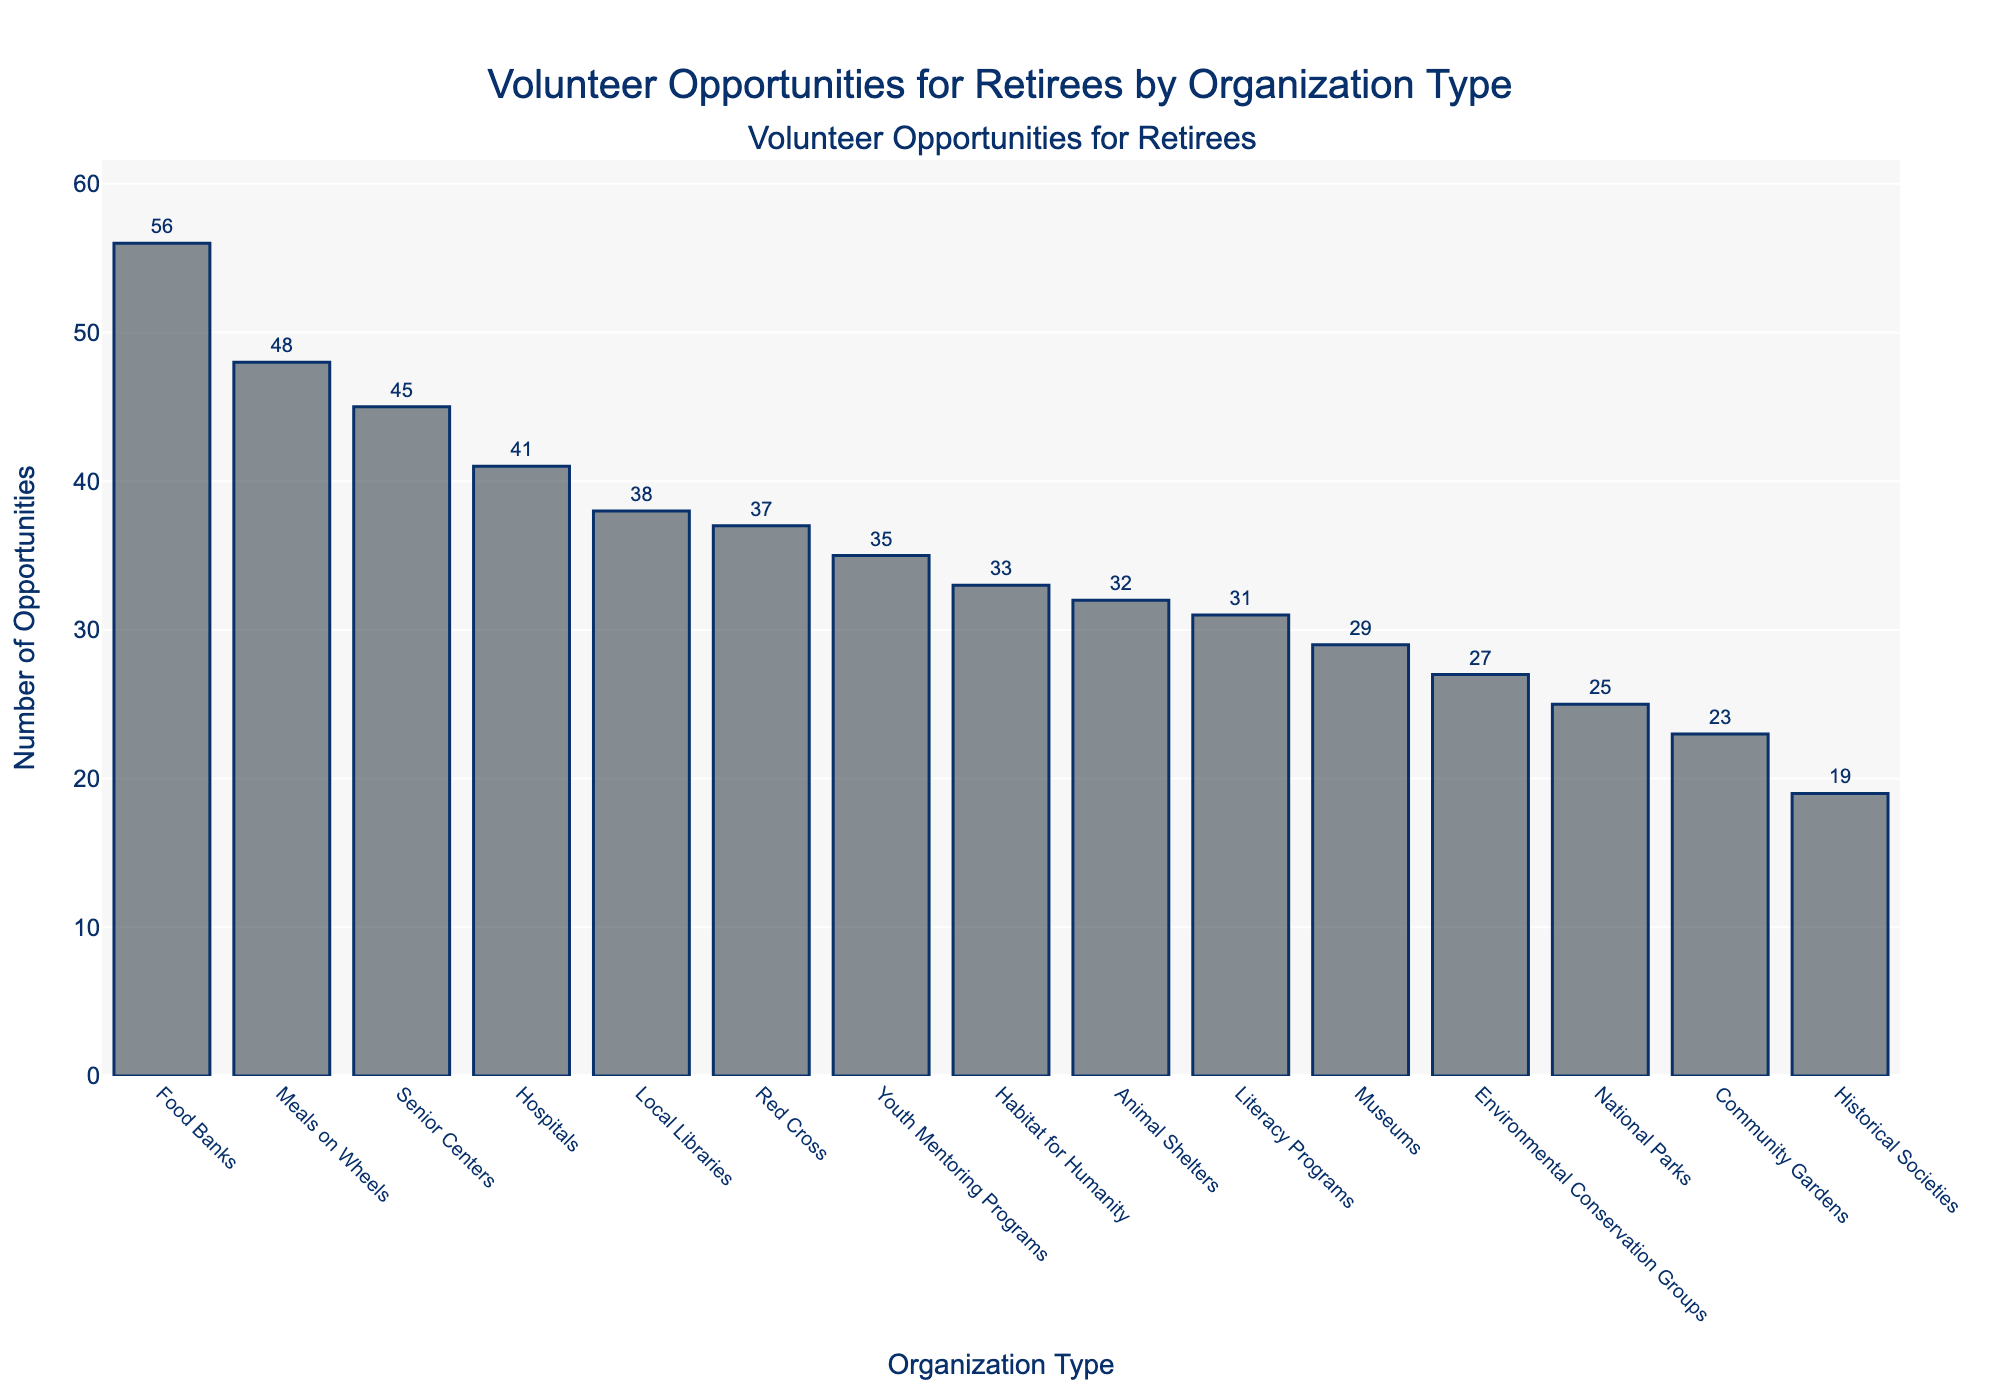Which organization type offers the most volunteer opportunities? To find the organization with the most volunteer opportunities, look for the tallest bar in the chart. The tallest bar represents "Food Banks" with 56 opportunities.
Answer: Food Banks What is the difference in the number of volunteer opportunities between Senior Centers and Hospitals? Identify the number of volunteer opportunities for Senior Centers (45) and for Hospitals (41). Subtract the smaller number from the larger one: 45 - 41 = 4.
Answer: 4 How many volunteer opportunities are available in total for Animal Shelters and Local Libraries combined? Find the number of opportunities for both Animal Shelters (32) and Local Libraries (38). Add these numbers together: 32 + 38 = 70.
Answer: 70 Is there any organization type with fewer than 20 volunteer opportunities? If so, which one? Look for bars that represent less than 20 opportunities. The bar for Historical Societies is the only one representing fewer than 20 opportunities, with 19.
Answer: Yes, Historical Societies Among Environmental Conservation Groups and National Parks, which offers more volunteer opportunities and by how much? Find the number of opportunities for Environmental Conservation Groups (27) and National Parks (25). Subtract the smaller number from the larger: 27 - 25 = 2.
Answer: Environmental Conservation Groups, by 2 What is the sum of volunteer opportunities for the three organizations with the fewest opportunities? Identify the three organizations with the smallest bars: Historical Societies (19), Community Gardens (23), and National Parks (25). Add these numbers together: 19 + 23 + 25 = 67.
Answer: 67 Do Meals on Wheels offer more or fewer volunteer opportunities than Youth Mentoring Programs? Compare the number of opportunities for Meals on Wheels (48) and Youth Mentoring Programs (35). Meals on Wheels offer more.
Answer: More Which type of organization has the second highest number of volunteer opportunities? Identify the second tallest bar after Food Banks. The second tallest bar represents Meals on Wheels, which has 48 opportunities.
Answer: Meals on Wheels What is the average number of volunteer opportunities across all organization types? Sum the total number of volunteer opportunities and divide by the number of organization types. The total number is 483 (sum of all individual opportunities), and there are 15 organization types. So, 483 / 15 = 32.2.
Answer: 32.2 